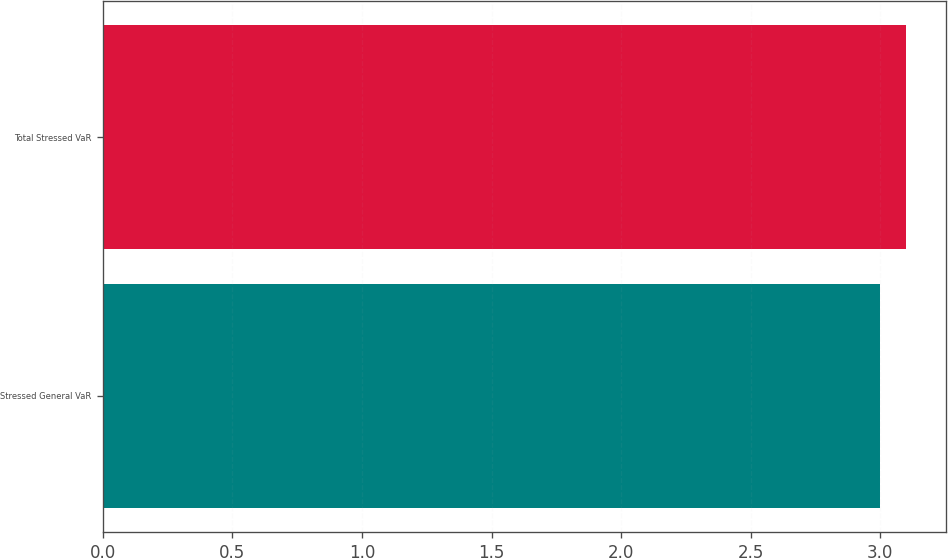Convert chart to OTSL. <chart><loc_0><loc_0><loc_500><loc_500><bar_chart><fcel>Stressed General VaR<fcel>Total Stressed VaR<nl><fcel>3<fcel>3.1<nl></chart> 